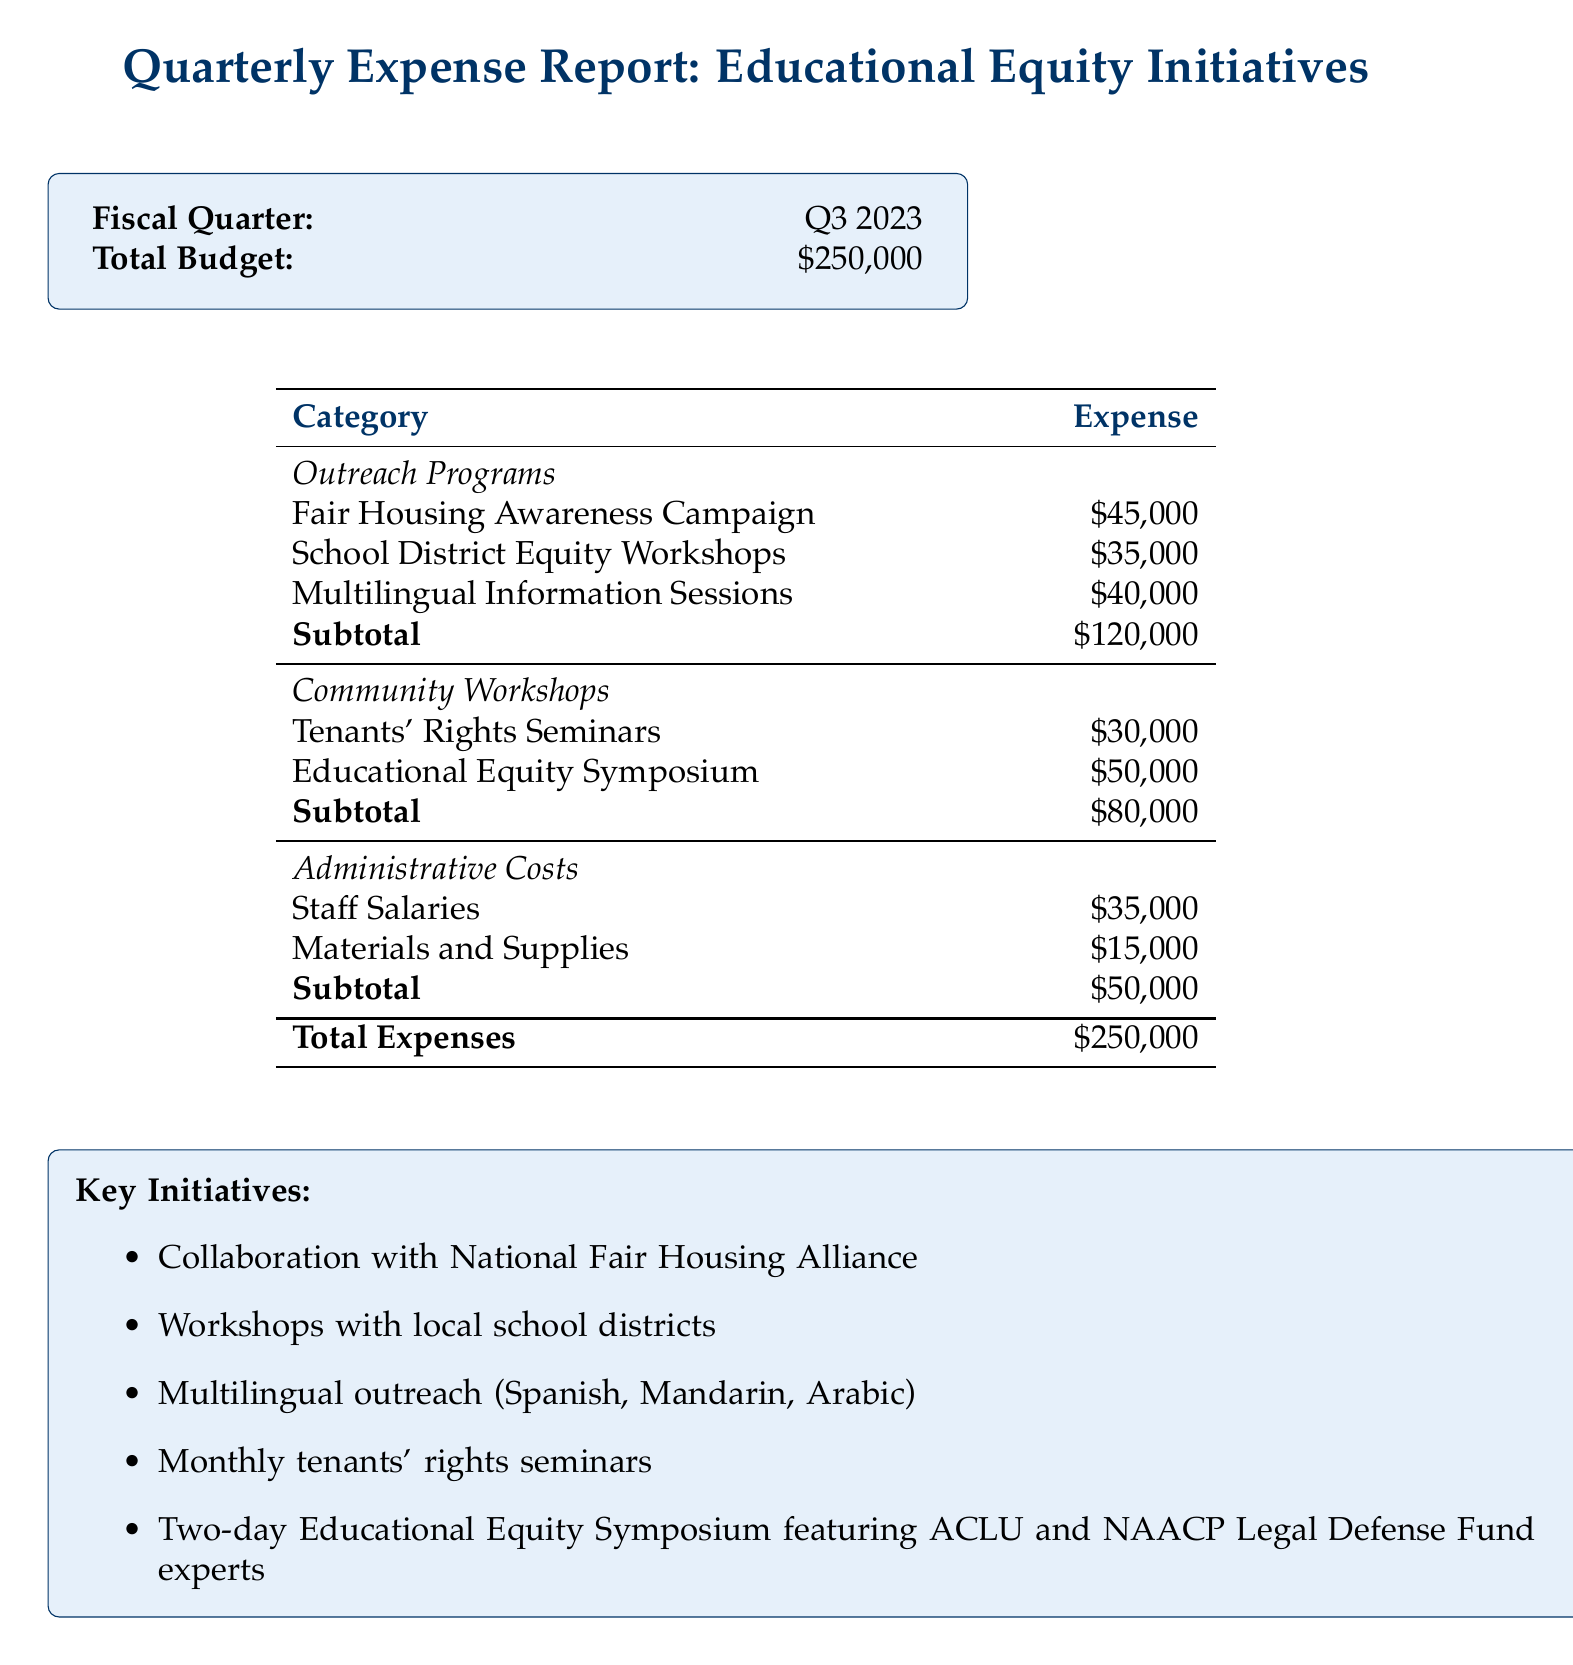What is the total budget? The total budget is specified at the top of the document, amounting to $250,000.
Answer: $250,000 How much was allocated for the Fair Housing Awareness Campaign? The document lists the expense for this specific outreach program, which is $45,000.
Answer: $45,000 What are the total expenses for Community Workshops? The total expenses for Community Workshops can be calculated by adding the costs of Tenants' Rights Seminars and Educational Equity Symposium, amounting to $80,000.
Answer: $80,000 What is the cost of School District Equity Workshops? This expense is specified in the outreach programs section of the document.
Answer: $35,000 How much was spent on administrative costs? The administrative costs are detailed in the document, totaling $50,000.
Answer: $50,000 Which organization partnered for the Fair Housing initiatives? The document mentions collaboration with a specific organization.
Answer: National Fair Housing Alliance What language was included in the multilingual outreach efforts? The key initiatives section lists the languages targeted in outreach programs, which are specifically mentioned.
Answer: Spanish, Mandarin, Arabic How many key initiatives are outlined in the document? The key initiatives section provides a list of specific actions, and counting them gives the total.
Answer: Five What is the budget for the Educational Equity Symposium? The expense for this particular community workshop is stated clearly in the document.
Answer: $50,000 What is the fiscal quarter for this report? The fiscal quarter is indicated prominently at the beginning of the document.
Answer: Q3 2023 